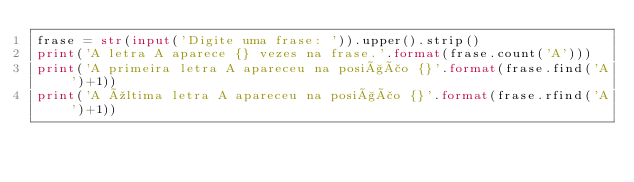<code> <loc_0><loc_0><loc_500><loc_500><_Python_>frase = str(input('Digite uma frase: ')).upper().strip()
print('A letra A aparece {} vezes na frase.'.format(frase.count('A')))
print('A primeira letra A apareceu na posição {}'.format(frase.find('A')+1))
print('A última letra A apareceu na posição {}'.format(frase.rfind('A')+1))

</code> 